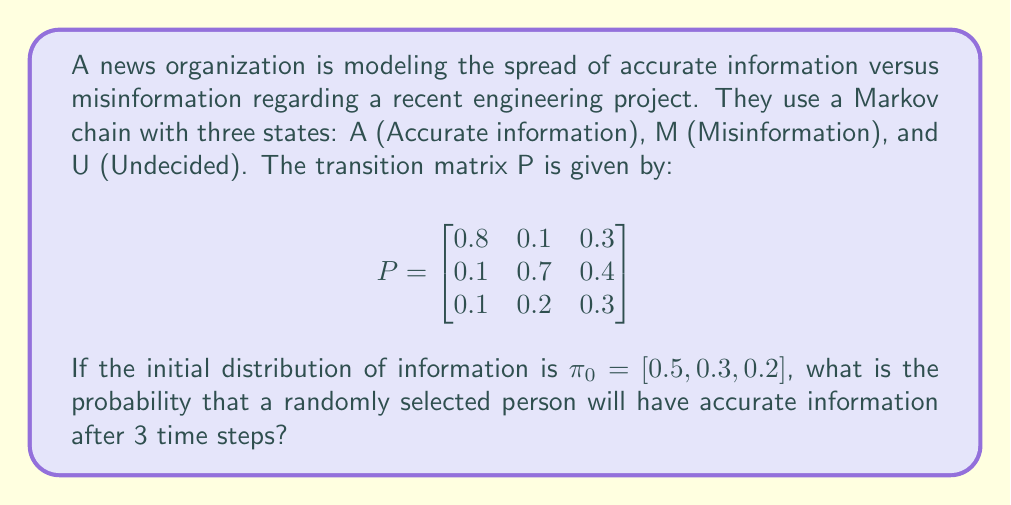What is the answer to this math problem? To solve this problem, we need to use the properties of Markov chains and matrix multiplication. Let's approach this step-by-step:

1) The initial distribution is given as $\pi_0 = [0.5, 0.3, 0.2]$.

2) To find the distribution after 3 time steps, we need to multiply $\pi_0$ by $P^3$ (the transition matrix raised to the power of 3).

3) First, let's calculate $P^2$:

   $$P^2 = P \times P = \begin{bmatrix}
   0.67 & 0.22 & 0.33 \\
   0.22 & 0.54 & 0.37 \\
   0.11 & 0.24 & 0.30
   \end{bmatrix}$$

4) Now, let's calculate $P^3$:

   $$P^3 = P^2 \times P = \begin{bmatrix}
   0.614 & 0.286 & 0.339 \\
   0.286 & 0.457 & 0.367 \\
   0.100 & 0.257 & 0.294
   \end{bmatrix}$$

5) Now we can multiply $\pi_0$ by $P^3$:

   $$\pi_3 = \pi_0 \times P^3 = [0.5, 0.3, 0.2] \times \begin{bmatrix}
   0.614 & 0.286 & 0.339 \\
   0.286 & 0.457 & 0.367 \\
   0.100 & 0.257 & 0.294
   \end{bmatrix}$$

6) Performing this multiplication:

   $$\pi_3 = [0.4456, 0.3359, 0.2185]$$

7) The probability of having accurate information after 3 time steps is the first element of $\pi_3$, which is approximately 0.4456 or 44.56%.

This result shows that despite starting with 50% accurate information, after 3 time steps, the proportion of people with accurate information has decreased to about 44.56%. This highlights the importance of continual efforts to disseminate accurate information in the face of competing misinformation.
Answer: The probability that a randomly selected person will have accurate information after 3 time steps is approximately 0.4456 or 44.56%. 